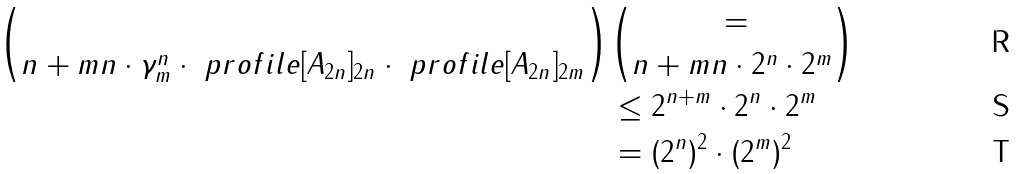Convert formula to latex. <formula><loc_0><loc_0><loc_500><loc_500>\choose { n + m } { n } \cdot \gamma ^ { n } _ { m } \cdot \ p r o f i l e [ A _ { 2 n } ] _ { 2 n } \cdot \ p r o f i l e [ A _ { 2 n } ] _ { 2 m } & = \choose { n + m } { n } \cdot 2 ^ { n } \cdot 2 ^ { m } \\ & \leq 2 ^ { n + m } \cdot 2 ^ { n } \cdot 2 ^ { m } \\ & = ( 2 ^ { n } ) ^ { 2 } \cdot ( 2 ^ { m } ) ^ { 2 }</formula> 